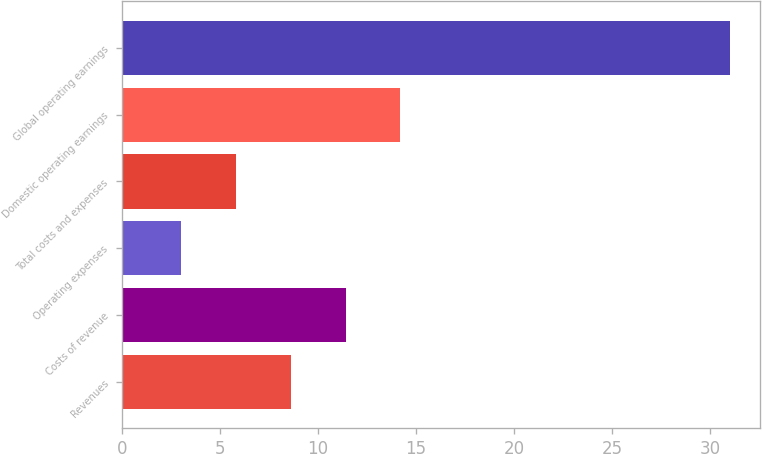<chart> <loc_0><loc_0><loc_500><loc_500><bar_chart><fcel>Revenues<fcel>Costs of revenue<fcel>Operating expenses<fcel>Total costs and expenses<fcel>Domestic operating earnings<fcel>Global operating earnings<nl><fcel>8.6<fcel>11.4<fcel>3<fcel>5.8<fcel>14.2<fcel>31<nl></chart> 